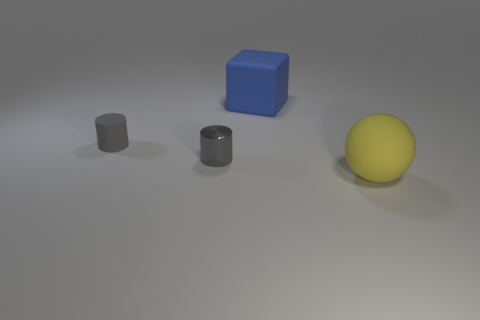Add 3 small brown shiny spheres. How many objects exist? 7 Subtract all blocks. How many objects are left? 3 Add 4 large purple cylinders. How many large purple cylinders exist? 4 Subtract 0 yellow blocks. How many objects are left? 4 Subtract all purple cylinders. Subtract all red spheres. How many cylinders are left? 2 Subtract all cubes. Subtract all rubber spheres. How many objects are left? 2 Add 4 large yellow things. How many large yellow things are left? 5 